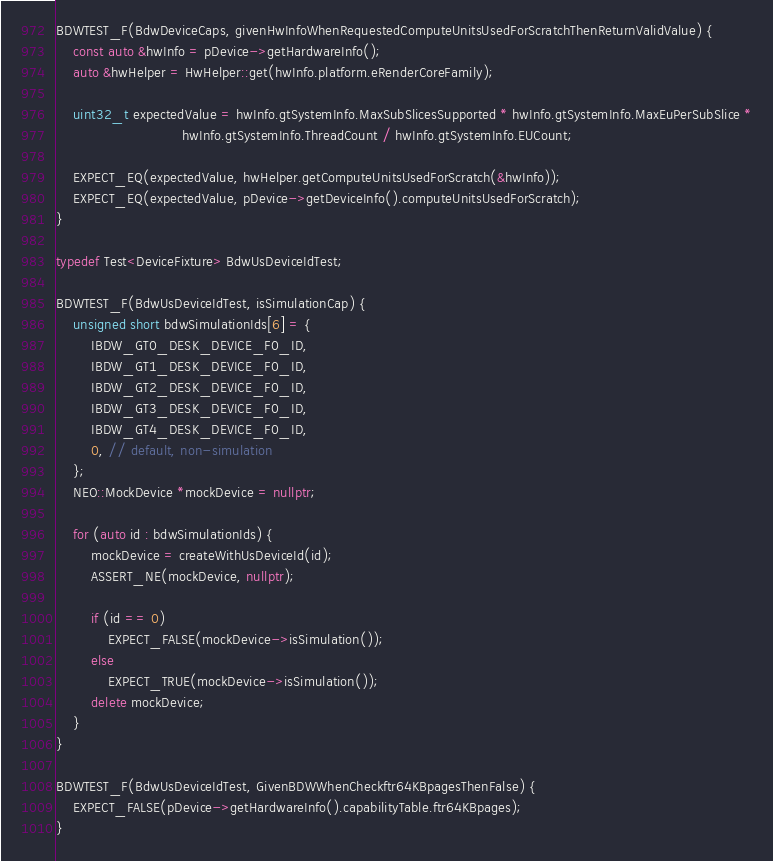<code> <loc_0><loc_0><loc_500><loc_500><_C++_>BDWTEST_F(BdwDeviceCaps, givenHwInfoWhenRequestedComputeUnitsUsedForScratchThenReturnValidValue) {
    const auto &hwInfo = pDevice->getHardwareInfo();
    auto &hwHelper = HwHelper::get(hwInfo.platform.eRenderCoreFamily);

    uint32_t expectedValue = hwInfo.gtSystemInfo.MaxSubSlicesSupported * hwInfo.gtSystemInfo.MaxEuPerSubSlice *
                             hwInfo.gtSystemInfo.ThreadCount / hwInfo.gtSystemInfo.EUCount;

    EXPECT_EQ(expectedValue, hwHelper.getComputeUnitsUsedForScratch(&hwInfo));
    EXPECT_EQ(expectedValue, pDevice->getDeviceInfo().computeUnitsUsedForScratch);
}

typedef Test<DeviceFixture> BdwUsDeviceIdTest;

BDWTEST_F(BdwUsDeviceIdTest, isSimulationCap) {
    unsigned short bdwSimulationIds[6] = {
        IBDW_GT0_DESK_DEVICE_F0_ID,
        IBDW_GT1_DESK_DEVICE_F0_ID,
        IBDW_GT2_DESK_DEVICE_F0_ID,
        IBDW_GT3_DESK_DEVICE_F0_ID,
        IBDW_GT4_DESK_DEVICE_F0_ID,
        0, // default, non-simulation
    };
    NEO::MockDevice *mockDevice = nullptr;

    for (auto id : bdwSimulationIds) {
        mockDevice = createWithUsDeviceId(id);
        ASSERT_NE(mockDevice, nullptr);

        if (id == 0)
            EXPECT_FALSE(mockDevice->isSimulation());
        else
            EXPECT_TRUE(mockDevice->isSimulation());
        delete mockDevice;
    }
}

BDWTEST_F(BdwUsDeviceIdTest, GivenBDWWhenCheckftr64KBpagesThenFalse) {
    EXPECT_FALSE(pDevice->getHardwareInfo().capabilityTable.ftr64KBpages);
}
</code> 